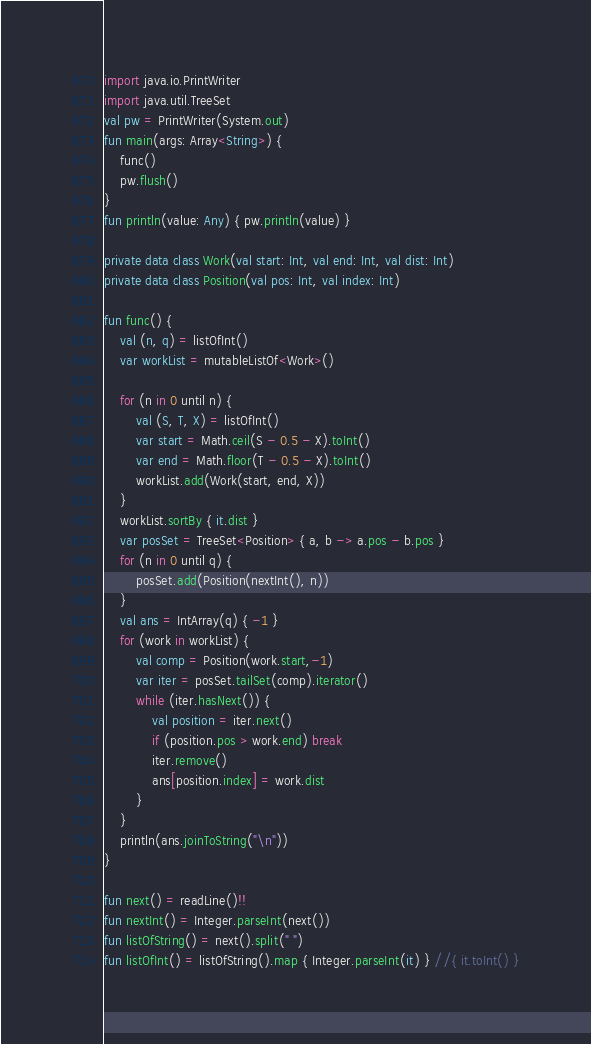<code> <loc_0><loc_0><loc_500><loc_500><_Kotlin_>import java.io.PrintWriter
import java.util.TreeSet
val pw = PrintWriter(System.out)
fun main(args: Array<String>) {
    func()
    pw.flush()
}
fun println(value: Any) { pw.println(value) }

private data class Work(val start: Int, val end: Int, val dist: Int)
private data class Position(val pos: Int, val index: Int)

fun func() {
    val (n, q) = listOfInt()
    var workList = mutableListOf<Work>()

    for (n in 0 until n) {
        val (S, T, X) = listOfInt()
        var start = Math.ceil(S - 0.5 - X).toInt()
        var end = Math.floor(T - 0.5 - X).toInt()
        workList.add(Work(start, end, X))
    }
    workList.sortBy { it.dist }
    var posSet = TreeSet<Position> { a, b -> a.pos - b.pos }
    for (n in 0 until q) {
        posSet.add(Position(nextInt(), n))
    }
    val ans = IntArray(q) { -1 }
    for (work in workList) {
        val comp = Position(work.start,-1)
        var iter = posSet.tailSet(comp).iterator()
        while (iter.hasNext()) {
            val position = iter.next()
            if (position.pos > work.end) break
            iter.remove()
            ans[position.index] = work.dist
        }
    }
    println(ans.joinToString("\n"))
}

fun next() = readLine()!!
fun nextInt() = Integer.parseInt(next())
fun listOfString() = next().split(" ")
fun listOfInt() = listOfString().map { Integer.parseInt(it) } //{ it.toInt() }
</code> 